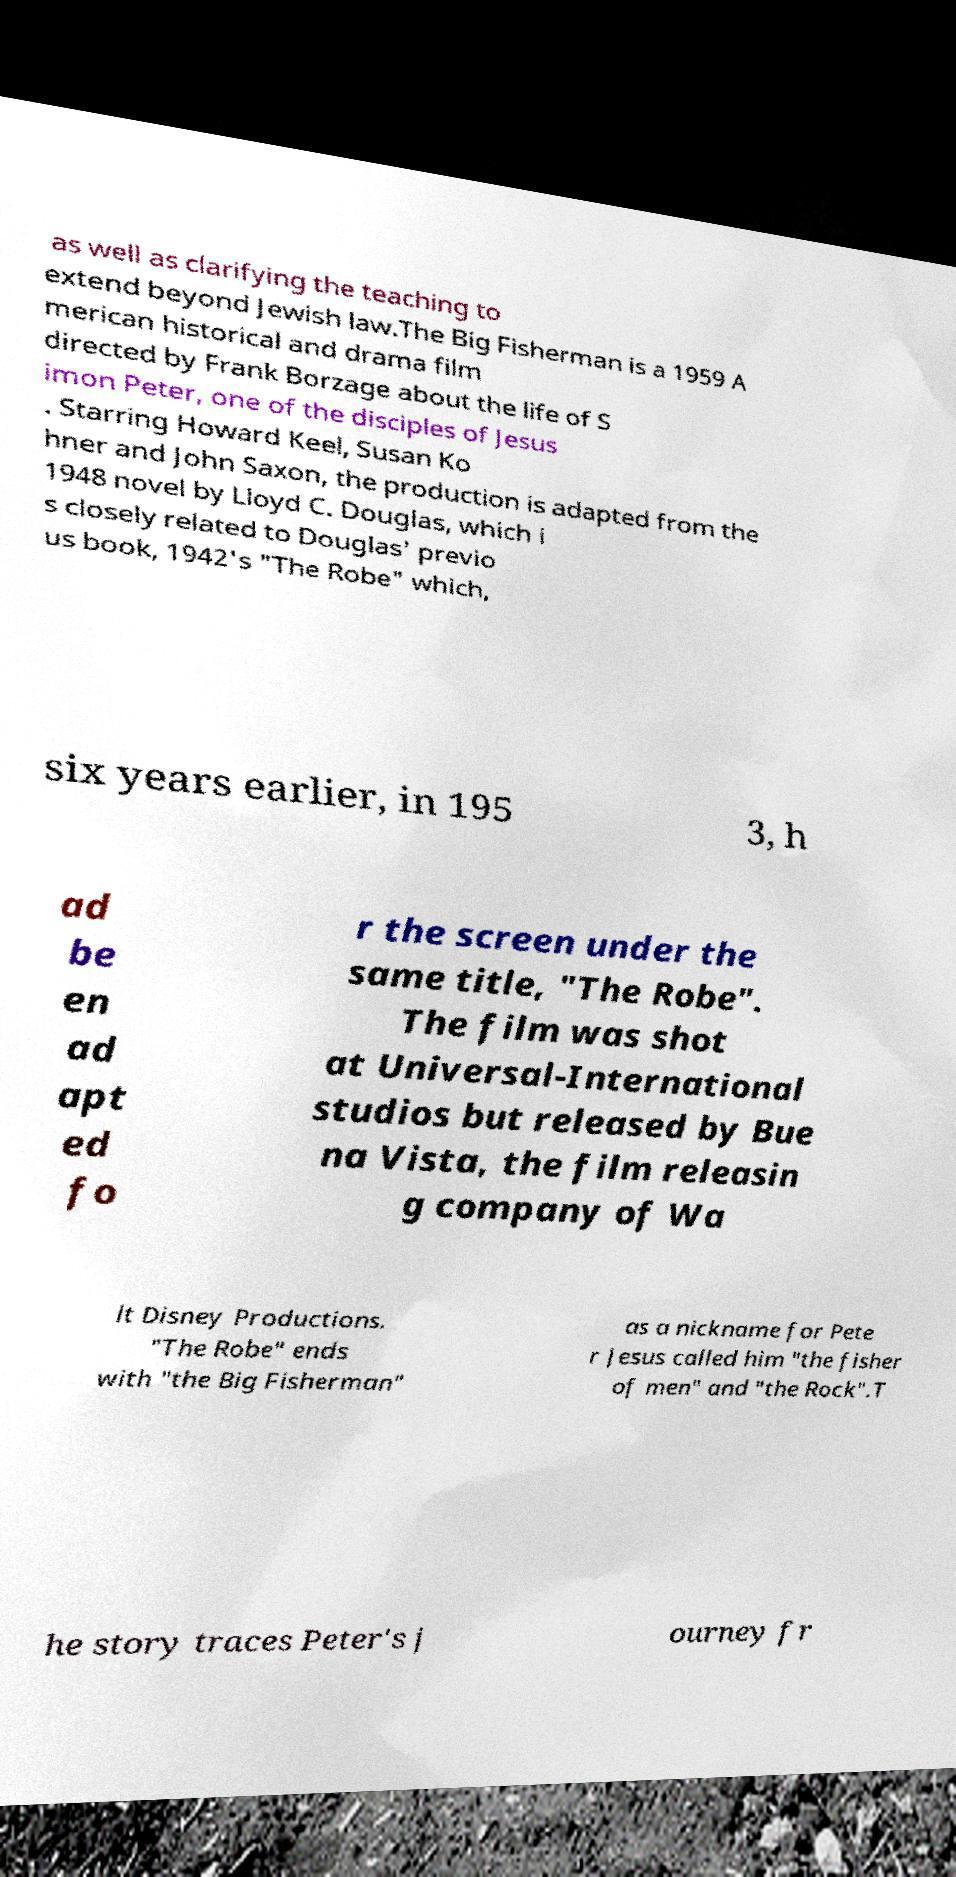For documentation purposes, I need the text within this image transcribed. Could you provide that? as well as clarifying the teaching to extend beyond Jewish law.The Big Fisherman is a 1959 A merican historical and drama film directed by Frank Borzage about the life of S imon Peter, one of the disciples of Jesus . Starring Howard Keel, Susan Ko hner and John Saxon, the production is adapted from the 1948 novel by Lloyd C. Douglas, which i s closely related to Douglas' previo us book, 1942's "The Robe" which, six years earlier, in 195 3, h ad be en ad apt ed fo r the screen under the same title, "The Robe". The film was shot at Universal-International studios but released by Bue na Vista, the film releasin g company of Wa lt Disney Productions. "The Robe" ends with "the Big Fisherman" as a nickname for Pete r Jesus called him "the fisher of men" and "the Rock".T he story traces Peter's j ourney fr 